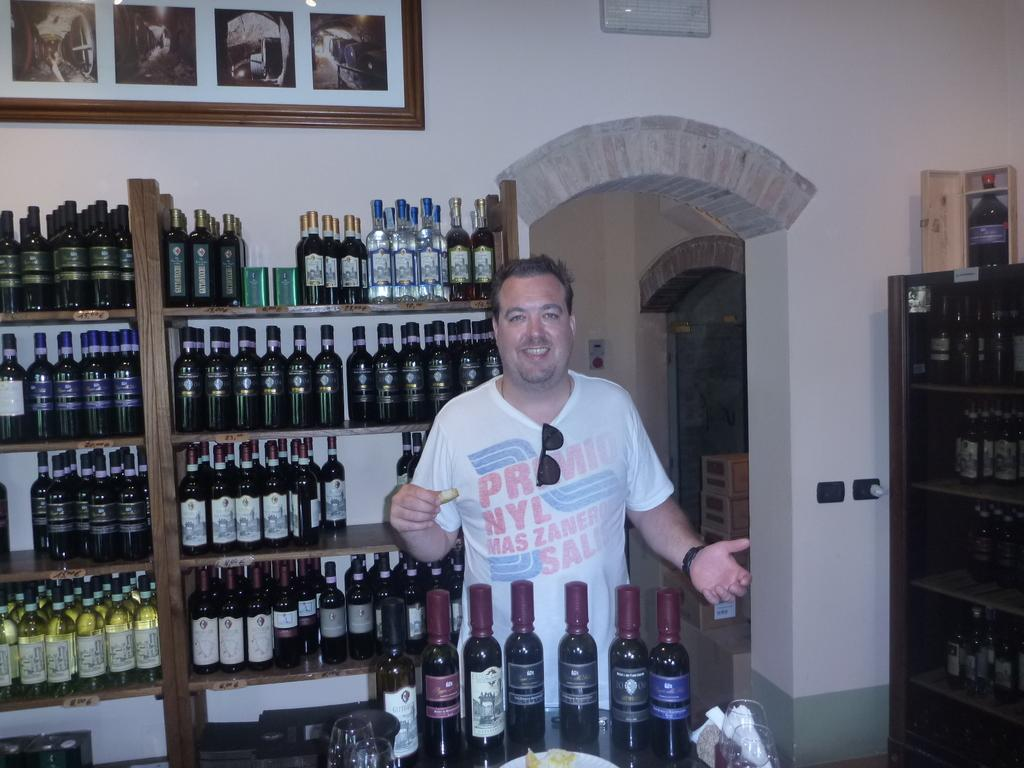<image>
Write a terse but informative summary of the picture. A man in a shirt that says "primio" at the top has his sunglasses tucked into his collar. 